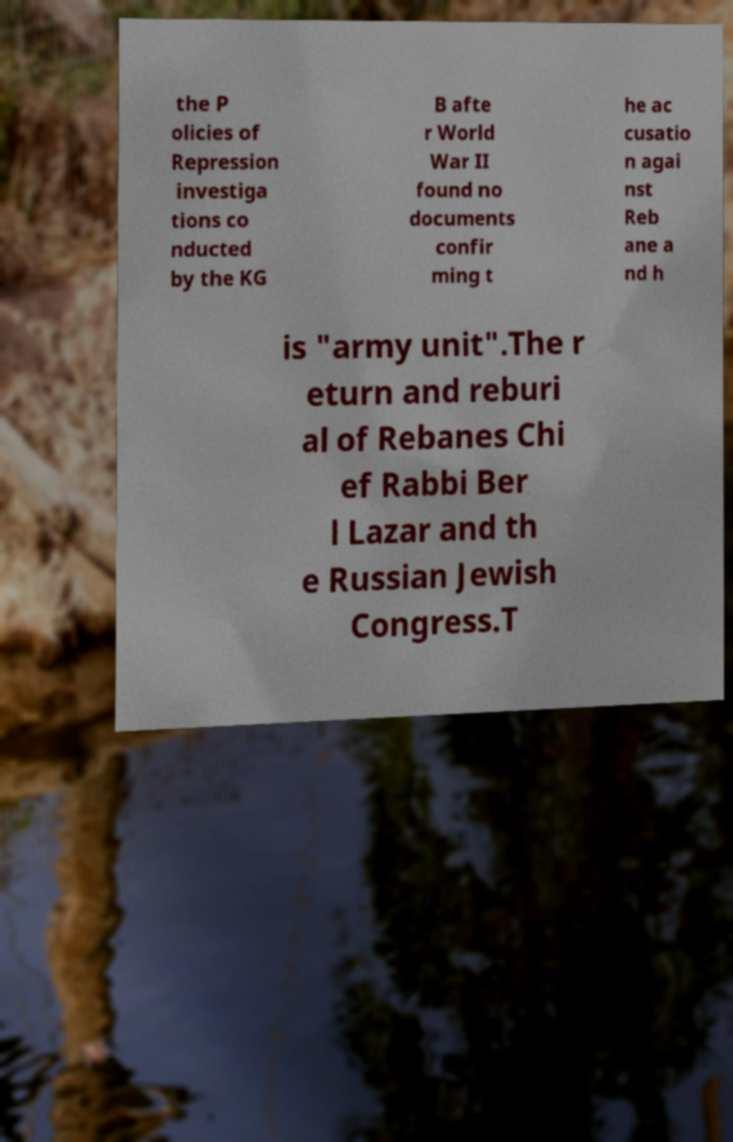What messages or text are displayed in this image? I need them in a readable, typed format. the P olicies of Repression investiga tions co nducted by the KG B afte r World War II found no documents confir ming t he ac cusatio n agai nst Reb ane a nd h is "army unit".The r eturn and reburi al of Rebanes Chi ef Rabbi Ber l Lazar and th e Russian Jewish Congress.T 